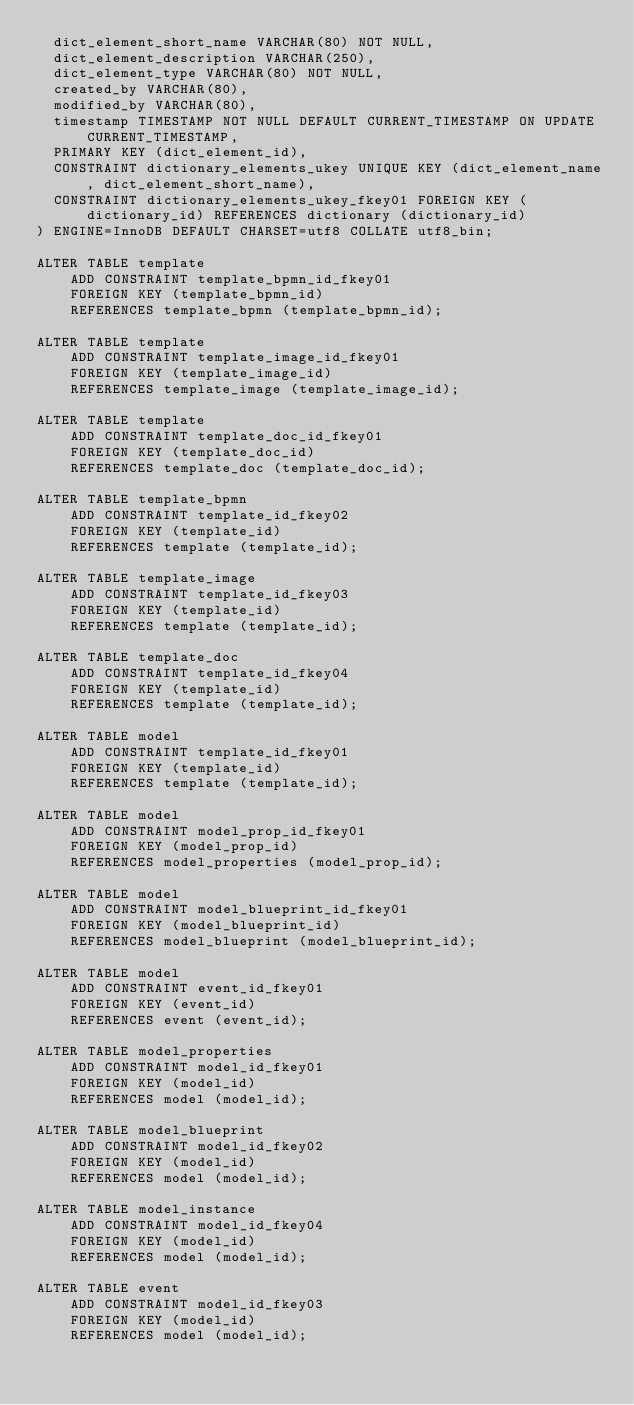Convert code to text. <code><loc_0><loc_0><loc_500><loc_500><_SQL_>  dict_element_short_name VARCHAR(80) NOT NULL,
  dict_element_description VARCHAR(250),
  dict_element_type VARCHAR(80) NOT NULL,
  created_by VARCHAR(80),
  modified_by VARCHAR(80),
  timestamp TIMESTAMP NOT NULL DEFAULT CURRENT_TIMESTAMP ON UPDATE CURRENT_TIMESTAMP,
  PRIMARY KEY (dict_element_id),
  CONSTRAINT dictionary_elements_ukey UNIQUE KEY (dict_element_name, dict_element_short_name),
  CONSTRAINT dictionary_elements_ukey_fkey01 FOREIGN KEY (dictionary_id) REFERENCES dictionary (dictionary_id)
) ENGINE=InnoDB DEFAULT CHARSET=utf8 COLLATE utf8_bin;

ALTER TABLE template
    ADD CONSTRAINT template_bpmn_id_fkey01
    FOREIGN KEY (template_bpmn_id)
    REFERENCES template_bpmn (template_bpmn_id);

ALTER TABLE template
    ADD CONSTRAINT template_image_id_fkey01
    FOREIGN KEY (template_image_id)
    REFERENCES template_image (template_image_id);

ALTER TABLE template
    ADD CONSTRAINT template_doc_id_fkey01
    FOREIGN KEY (template_doc_id)
    REFERENCES template_doc (template_doc_id);

ALTER TABLE template_bpmn
    ADD CONSTRAINT template_id_fkey02
    FOREIGN KEY (template_id)
    REFERENCES template (template_id);

ALTER TABLE template_image
    ADD CONSTRAINT template_id_fkey03
    FOREIGN KEY (template_id)
    REFERENCES template (template_id);

ALTER TABLE template_doc
    ADD CONSTRAINT template_id_fkey04
    FOREIGN KEY (template_id)
    REFERENCES template (template_id);

ALTER TABLE model
    ADD CONSTRAINT template_id_fkey01
    FOREIGN KEY (template_id)
    REFERENCES template (template_id);

ALTER TABLE model
    ADD CONSTRAINT model_prop_id_fkey01
    FOREIGN KEY (model_prop_id)
    REFERENCES model_properties (model_prop_id);

ALTER TABLE model
    ADD CONSTRAINT model_blueprint_id_fkey01
    FOREIGN KEY (model_blueprint_id)
    REFERENCES model_blueprint (model_blueprint_id);

ALTER TABLE model
    ADD CONSTRAINT event_id_fkey01
    FOREIGN KEY (event_id)
    REFERENCES event (event_id);

ALTER TABLE model_properties
    ADD CONSTRAINT model_id_fkey01
    FOREIGN KEY (model_id)
    REFERENCES model (model_id);

ALTER TABLE model_blueprint
    ADD CONSTRAINT model_id_fkey02
    FOREIGN KEY (model_id)
    REFERENCES model (model_id);

ALTER TABLE model_instance
    ADD CONSTRAINT model_id_fkey04
    FOREIGN KEY (model_id)
    REFERENCES model (model_id);

ALTER TABLE event
    ADD CONSTRAINT model_id_fkey03
    FOREIGN KEY (model_id)
    REFERENCES model (model_id);
</code> 